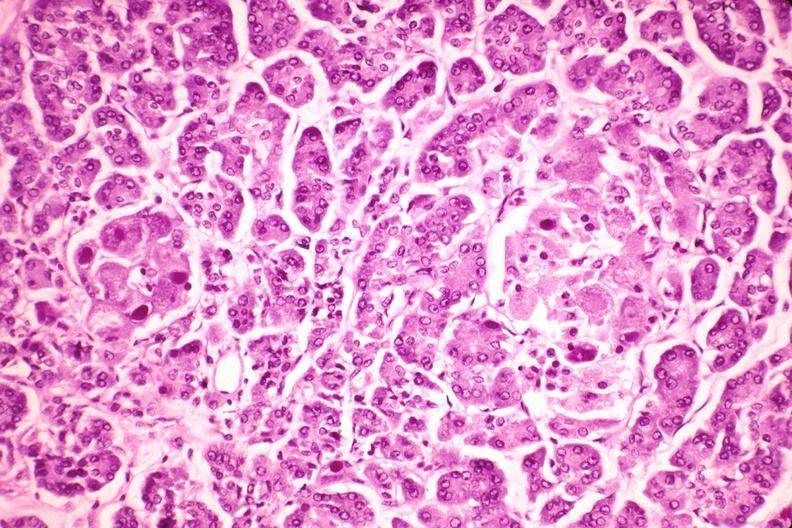does this image show pancreas, cytomegalovirus?
Answer the question using a single word or phrase. Yes 